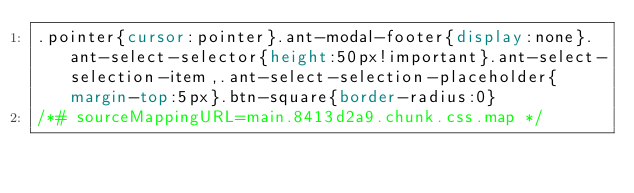Convert code to text. <code><loc_0><loc_0><loc_500><loc_500><_CSS_>.pointer{cursor:pointer}.ant-modal-footer{display:none}.ant-select-selector{height:50px!important}.ant-select-selection-item,.ant-select-selection-placeholder{margin-top:5px}.btn-square{border-radius:0}
/*# sourceMappingURL=main.8413d2a9.chunk.css.map */</code> 